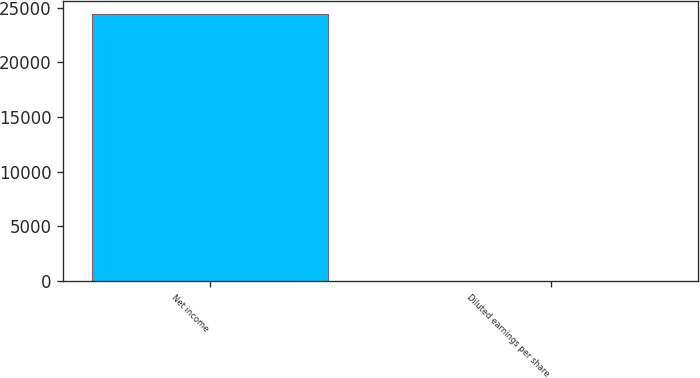Convert chart. <chart><loc_0><loc_0><loc_500><loc_500><bar_chart><fcel>Net income<fcel>Diluted earnings per share<nl><fcel>24395<fcel>0.51<nl></chart> 